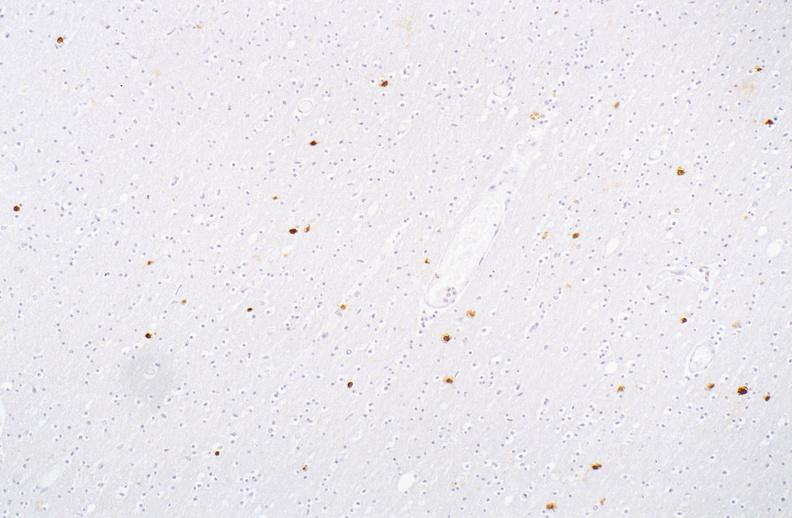s nervous present?
Answer the question using a single word or phrase. Yes 